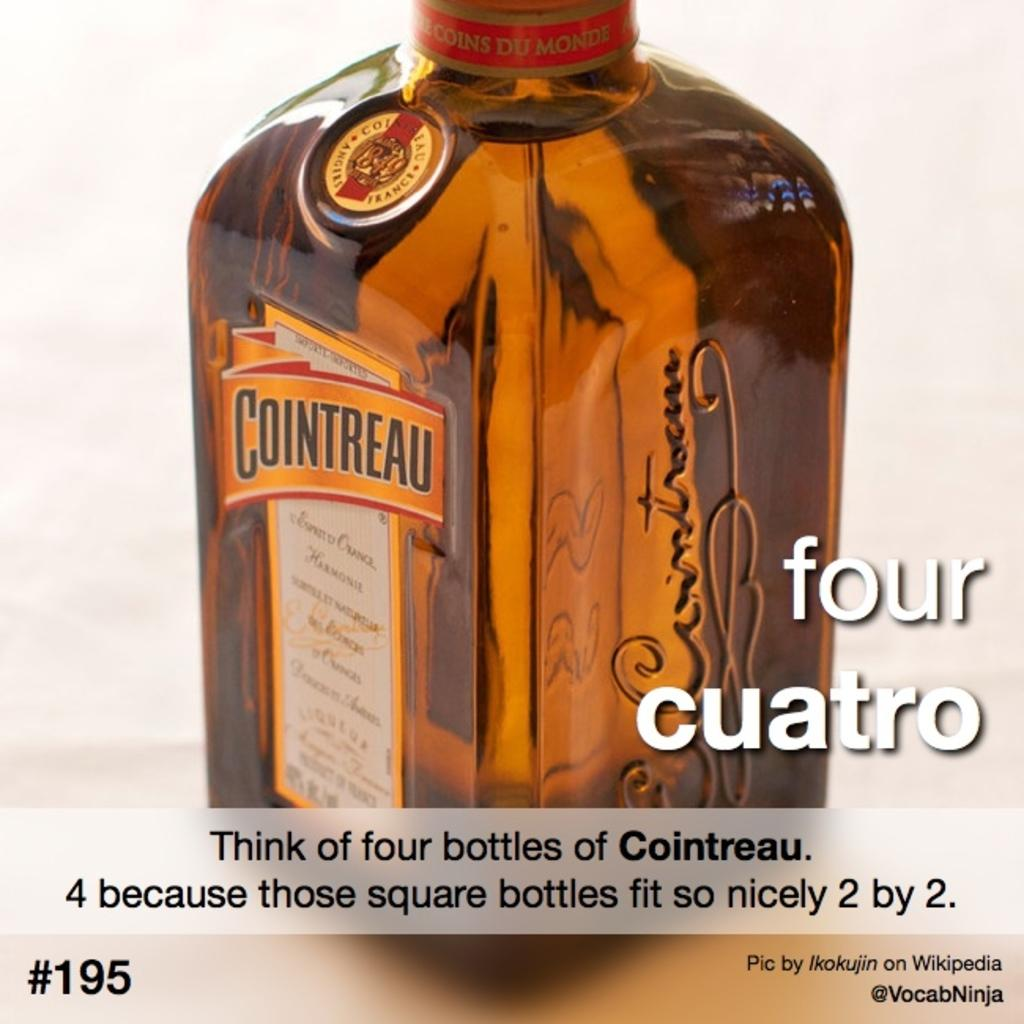<image>
Summarize the visual content of the image. The advertisement shows a bottle of cointreau sitting on a table. 